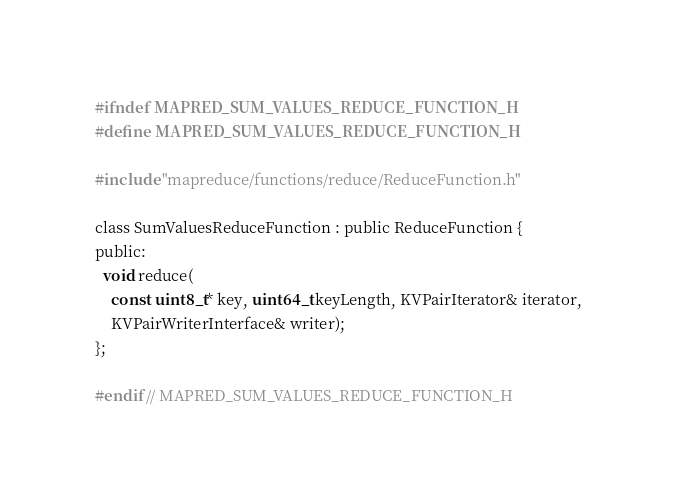<code> <loc_0><loc_0><loc_500><loc_500><_C_>#ifndef MAPRED_SUM_VALUES_REDUCE_FUNCTION_H
#define MAPRED_SUM_VALUES_REDUCE_FUNCTION_H

#include "mapreduce/functions/reduce/ReduceFunction.h"

class SumValuesReduceFunction : public ReduceFunction {
public:
  void reduce(
    const uint8_t* key, uint64_t keyLength, KVPairIterator& iterator,
    KVPairWriterInterface& writer);
};

#endif // MAPRED_SUM_VALUES_REDUCE_FUNCTION_H
</code> 